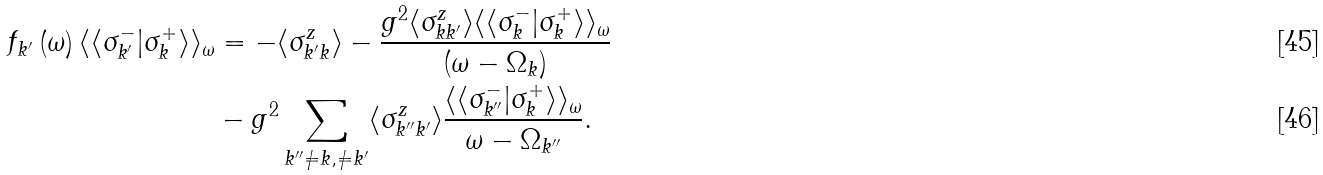Convert formula to latex. <formula><loc_0><loc_0><loc_500><loc_500>f _ { k ^ { \prime } } \left ( \omega \right ) \langle \langle \sigma _ { k ^ { \prime } } ^ { - } | \sigma _ { k } ^ { + } \rangle \rangle _ { \omega } & = - \langle \sigma _ { k ^ { \prime } k } ^ { z } \rangle - \frac { g ^ { 2 } \langle \sigma _ { k k ^ { \prime } } ^ { z } \rangle \langle \langle \sigma _ { k } ^ { - } | \sigma _ { k } ^ { + } \rangle \rangle _ { \omega } } { ( \omega - \Omega _ { k } ) } \\ & - g ^ { 2 } \sum _ { k ^ { \prime \prime } \neq k , \neq k ^ { \prime } } \langle \sigma _ { k ^ { \prime \prime } k ^ { \prime } } ^ { z } \rangle \frac { \langle \langle \sigma _ { k ^ { \prime \prime } } ^ { - } | \sigma _ { k } ^ { + } \rangle \rangle _ { \omega } } { \omega - \Omega _ { k ^ { \prime \prime } } } .</formula> 